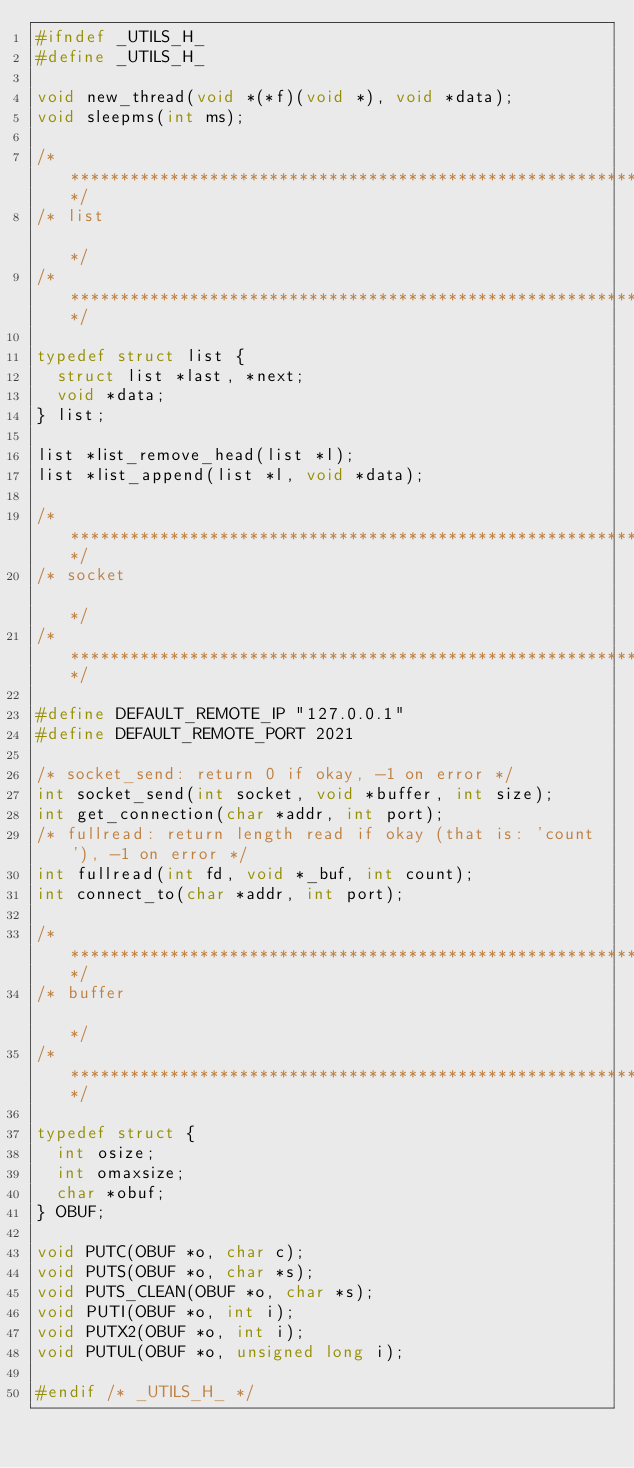Convert code to text. <code><loc_0><loc_0><loc_500><loc_500><_C_>#ifndef _UTILS_H_
#define _UTILS_H_

void new_thread(void *(*f)(void *), void *data);
void sleepms(int ms);

/****************************************************************************/
/* list                                                                     */
/****************************************************************************/

typedef struct list {
  struct list *last, *next;
  void *data;
} list;

list *list_remove_head(list *l);
list *list_append(list *l, void *data);

/****************************************************************************/
/* socket                                                                   */
/****************************************************************************/

#define DEFAULT_REMOTE_IP "127.0.0.1"
#define DEFAULT_REMOTE_PORT 2021

/* socket_send: return 0 if okay, -1 on error */
int socket_send(int socket, void *buffer, int size);
int get_connection(char *addr, int port);
/* fullread: return length read if okay (that is: 'count'), -1 on error */
int fullread(int fd, void *_buf, int count);
int connect_to(char *addr, int port);

/****************************************************************************/
/* buffer                                                                   */
/****************************************************************************/

typedef struct {
  int osize;
  int omaxsize;
  char *obuf;
} OBUF;

void PUTC(OBUF *o, char c);
void PUTS(OBUF *o, char *s);
void PUTS_CLEAN(OBUF *o, char *s);
void PUTI(OBUF *o, int i);
void PUTX2(OBUF *o, int i);
void PUTUL(OBUF *o, unsigned long i);

#endif /* _UTILS_H_ */
</code> 